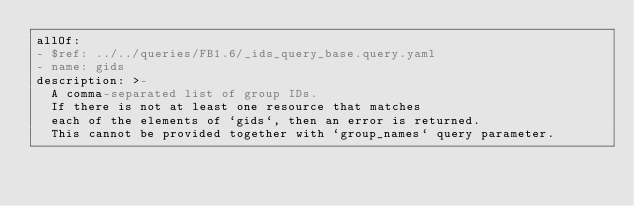Convert code to text. <code><loc_0><loc_0><loc_500><loc_500><_YAML_>allOf:
- $ref: ../../queries/FB1.6/_ids_query_base.query.yaml
- name: gids
description: >-
  A comma-separated list of group IDs.
  If there is not at least one resource that matches
  each of the elements of `gids`, then an error is returned.
  This cannot be provided together with `group_names` query parameter.
</code> 